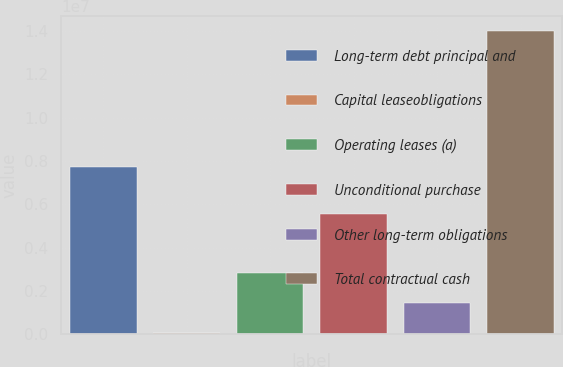Convert chart. <chart><loc_0><loc_0><loc_500><loc_500><bar_chart><fcel>Long-term debt principal and<fcel>Capital leaseobligations<fcel>Operating leases (a)<fcel>Unconditional purchase<fcel>Other long-term obligations<fcel>Total contractual cash<nl><fcel>7.72784e+06<fcel>62365<fcel>2.84933e+06<fcel>5.57772e+06<fcel>1.45585e+06<fcel>1.39972e+07<nl></chart> 